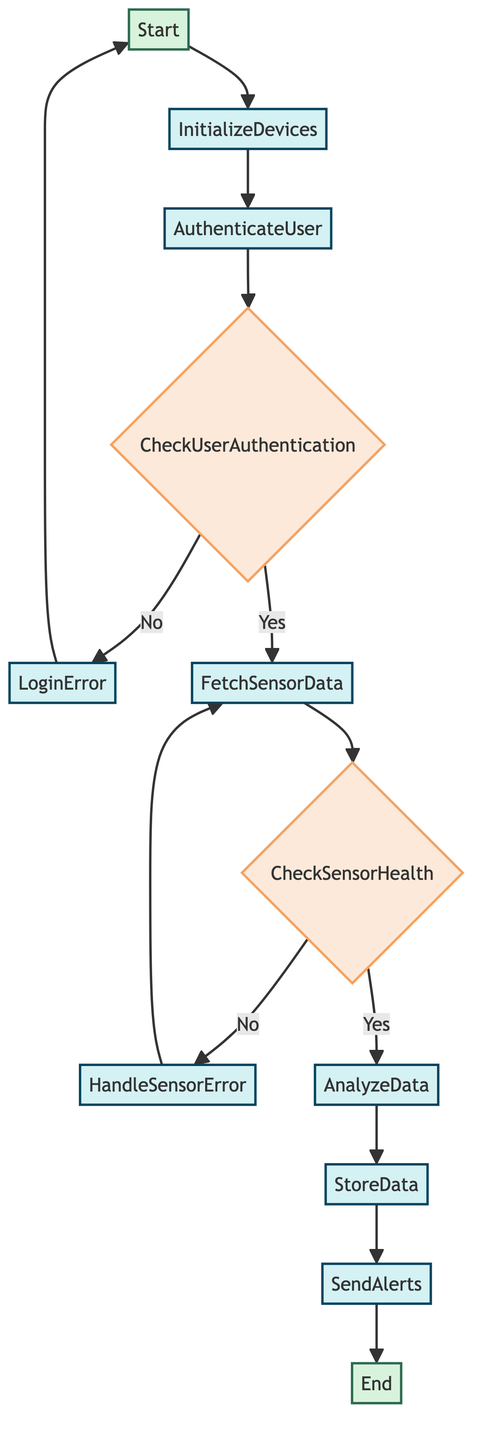What is the first process in the flowchart? The first process in the flowchart is 'InitializeDevices', which immediately follows the starting point 'Start'.
Answer: InitializeDevices What happens if user authentication fails? If user authentication fails, the flowchart directs to the process 'LoginError', which handles the error that arises from unsuccessful authentication.
Answer: LoginError How many decision nodes are present in the flowchart? The flowchart contains two decision nodes: 'CheckUserAuthentication' and 'CheckSensorHealth'.
Answer: 2 What process follows after 'FetchSensorData'? After 'FetchSensorData', the next process in the flowchart is 'CheckSensorHealth', where the health of the fetched sensor data is verified.
Answer: CheckSensorHealth What is the outcome if sensor data is invalid? If the sensor data is invalid, the flowchart leads to 'HandleSensorError', which deals with errors related to invalid sensor data.
Answer: HandleSensorError What process stores the analyzed health data? The process responsible for storing the analyzed health data in the cloud database is 'StoreData', which comes after 'AnalyzeData' in the flow.
Answer: StoreData Which function is called to send alerts? The function called to send alerts to healthcare providers based on the analysis results is 'send_alerts(analyzed_data)', which follows the 'StoreData' process.
Answer: send_alerts(analyzed_data) What does the decision node 'CheckSensorHealth' evaluate? The decision node 'CheckSensorHealth' evaluates whether the sensor data is valid and the sensors are healthy, determining the next step based on this evaluation.
Answer: is_sensor_healthy 